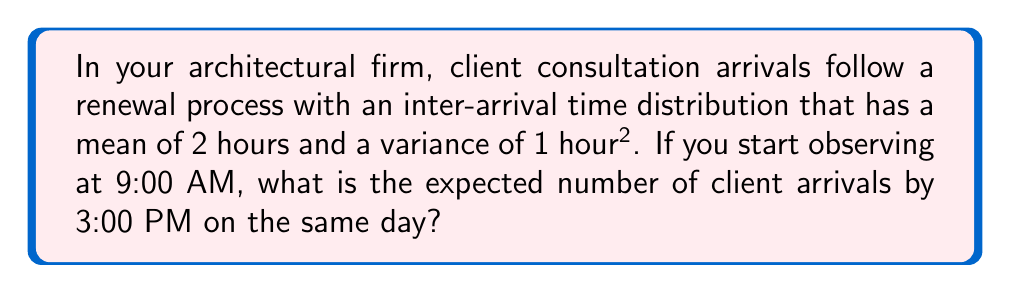Can you solve this math problem? Let's approach this step-by-step:

1) In a renewal process, the expected number of events $E[N(t)]$ in time $t$ is given by the renewal function:

   $$E[N(t)] \approx \frac{t}{\mu} + \frac{\sigma^2 - \mu^2}{2\mu^2}$$

   where $\mu$ is the mean inter-arrival time and $\sigma^2$ is the variance of inter-arrival times.

2) We're given:
   - Mean inter-arrival time, $\mu = 2$ hours
   - Variance of inter-arrival times, $\sigma^2 = 1$ hour^2
   - Observation period, $t = 6$ hours (from 9:00 AM to 3:00 PM)

3) Let's substitute these values into the formula:

   $$E[N(6)] \approx \frac{6}{2} + \frac{1 - 2^2}{2(2^2)}$$

4) Simplify:
   $$E[N(6)] \approx 3 + \frac{1 - 4}{8} = 3 - \frac{3}{8} = \frac{24 - 3}{8} = \frac{21}{8} = 2.625$$

5) Therefore, the expected number of client arrivals by 3:00 PM is approximately 2.625.
Answer: 2.625 client arrivals 